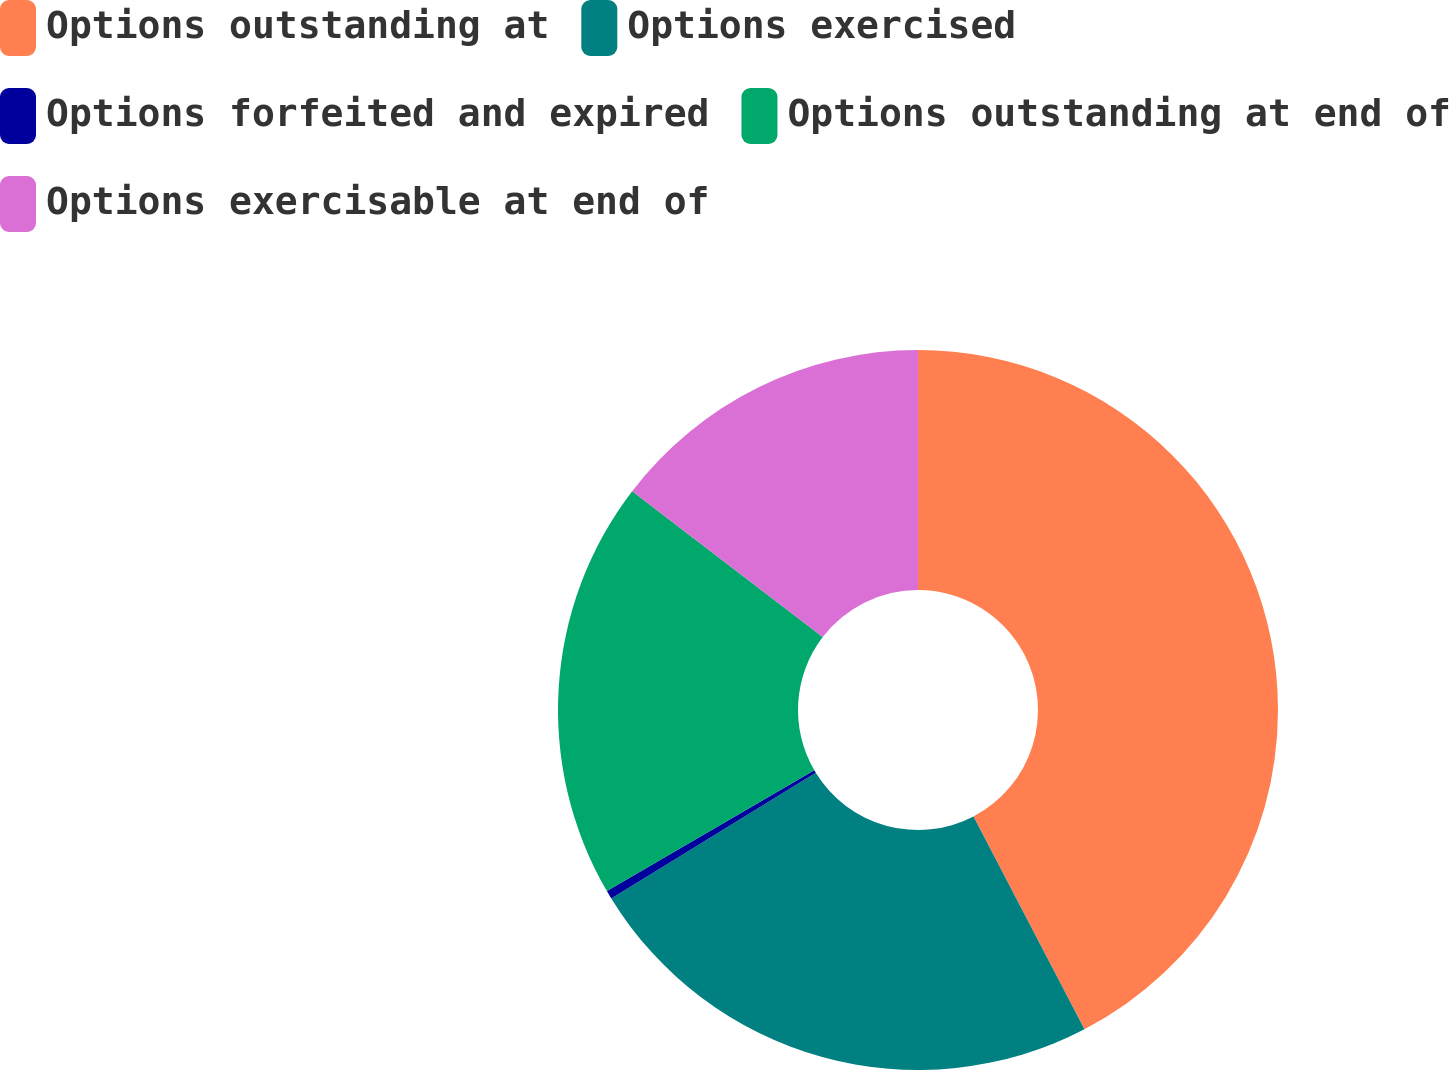Convert chart. <chart><loc_0><loc_0><loc_500><loc_500><pie_chart><fcel>Options outstanding at<fcel>Options exercised<fcel>Options forfeited and expired<fcel>Options outstanding at end of<fcel>Options exercisable at end of<nl><fcel>42.35%<fcel>23.88%<fcel>0.38%<fcel>18.79%<fcel>14.6%<nl></chart> 